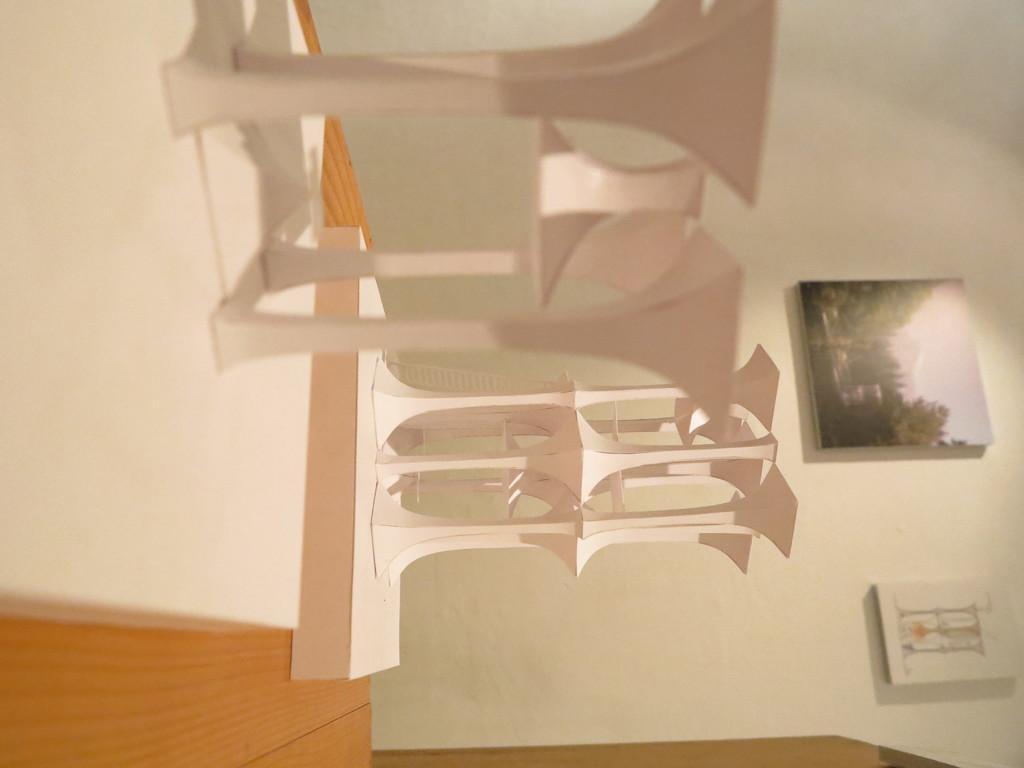Could you give a brief overview of what you see in this image? In this image we can see some objects on the wooden table, also we can see photo frames on the wall. 